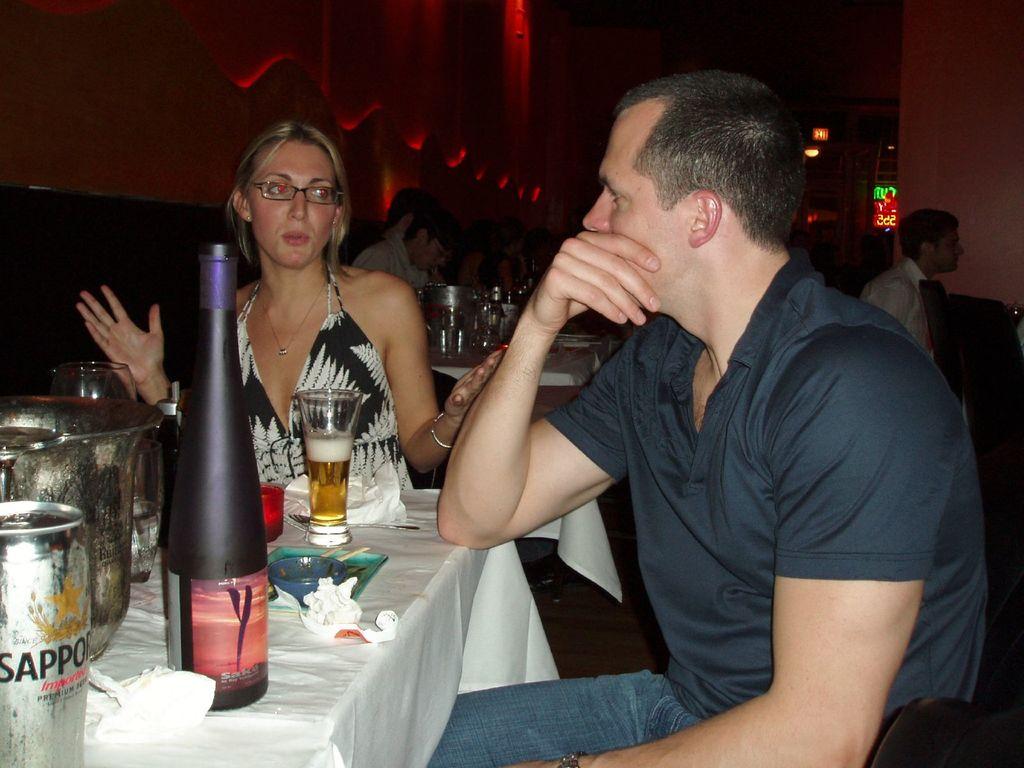What brand is the canned drink on the table?
Make the answer very short. Sapporo. What type of drink does the bottle say?
Your answer should be very brief. Sappo. 